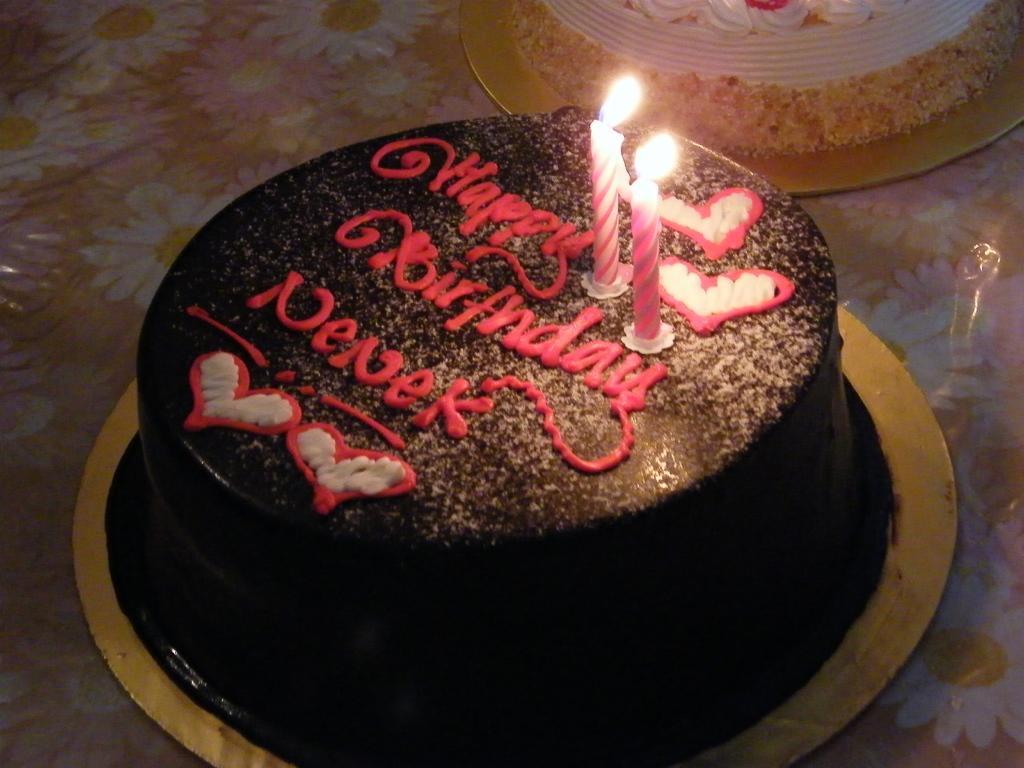Could you give a brief overview of what you see in this image? In this picture, there is a cake in the center with candles. On the top, there is another cake. 